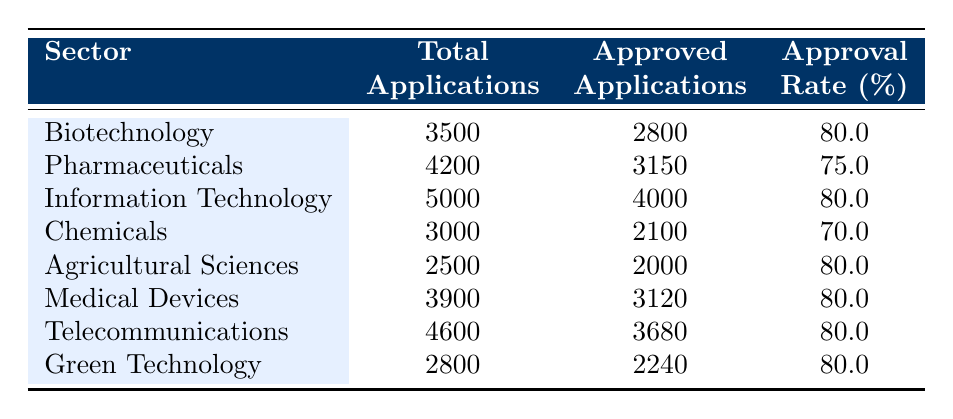What is the approval rate for the Biotechnology sector? The table shows the approval rate for Biotechnology is listed as 80.0%.
Answer: 80.0% How many total applications were submitted in the Pharmaceutical sector? The total applications for Pharmaceuticals is explicitly provided in the table as 4200.
Answer: 4200 Which sector has the lowest approval rate? By comparing the approval rates in the table, Chemicals has the lowest rate at 70.0%.
Answer: Chemicals What is the total number of approved applications in the Medical Devices sector? According to the table, the approved applications for Medical Devices is given as 3120.
Answer: 3120 How many more approved applications does the Information Technology sector have compared to the Pharmaceuticals sector? The approved applications for Information Technology is 4000, and for Pharmaceuticals, it is 3150. The difference is 4000 - 3150 = 850.
Answer: 850 What is the average approval rate for all sectors listed in the table? Calculate the average by summing the approval rates (80.0 + 75.0 + 80.0 + 70.0 + 80.0 + 80.0 + 80.0 + 80.0 = 625.0). Divide by the number of sectors (8) to get the average: 625.0 / 8 = 78.125.
Answer: 78.125 Is it true that the Agricultural Sciences sector has the same approval rate as the Biotechnology sector? Both sectors have an approval rate of 80.0%, which confirms that the statement is true.
Answer: True Which sector had the highest number of total applications submitted? The highest total applications are in the Information Technology sector with 5000 total applications listed in the table.
Answer: Information Technology What is the difference in total applications submitted between Pharmaceuticals and Green Technology? The table indicates Pharmaceuticals had 4200 total applications and Green Technology had 2800. The difference is 4200 - 2800 = 1400.
Answer: 1400 How many sectors have an approval rate of 80% or higher? By reviewing the table, Biotechnology, Information Technology, Agricultural Sciences, Medical Devices, Telecommunications, and Green Technology all have approval rates of 80% or higher, totaling 6 sectors.
Answer: 6 